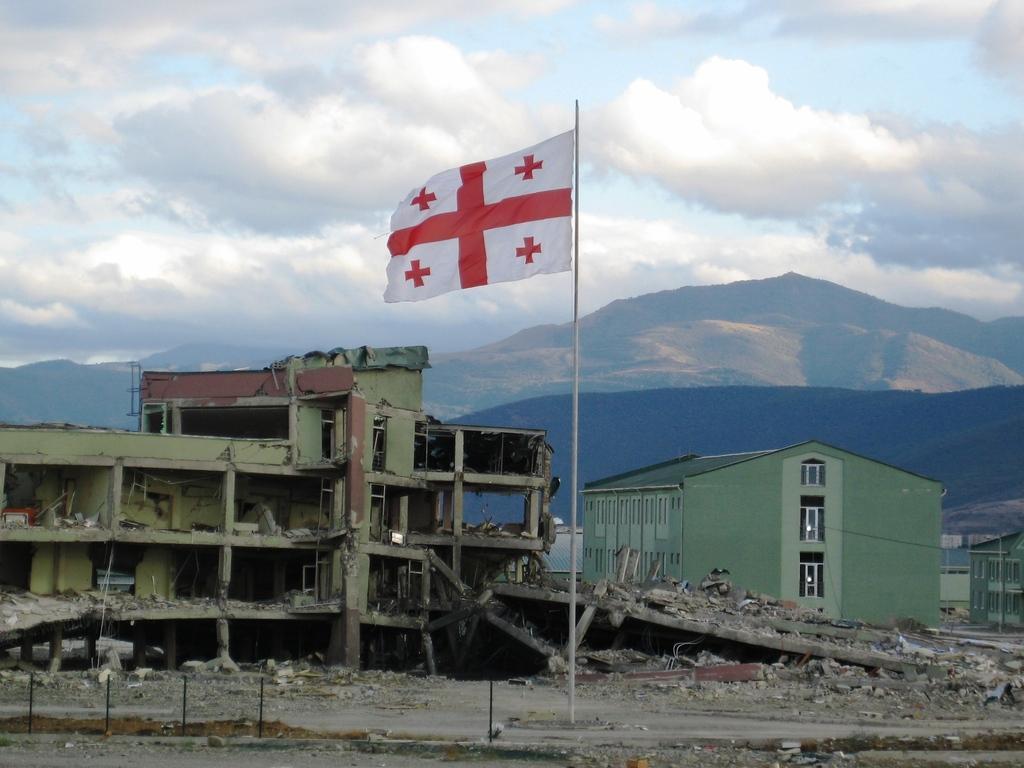Describe this image in one or two sentences. In this image I can see a white colored pole and a flag to it which is white and red in color, few other black colored poles and few buildings. In the background I can see few mountains and the sky. 